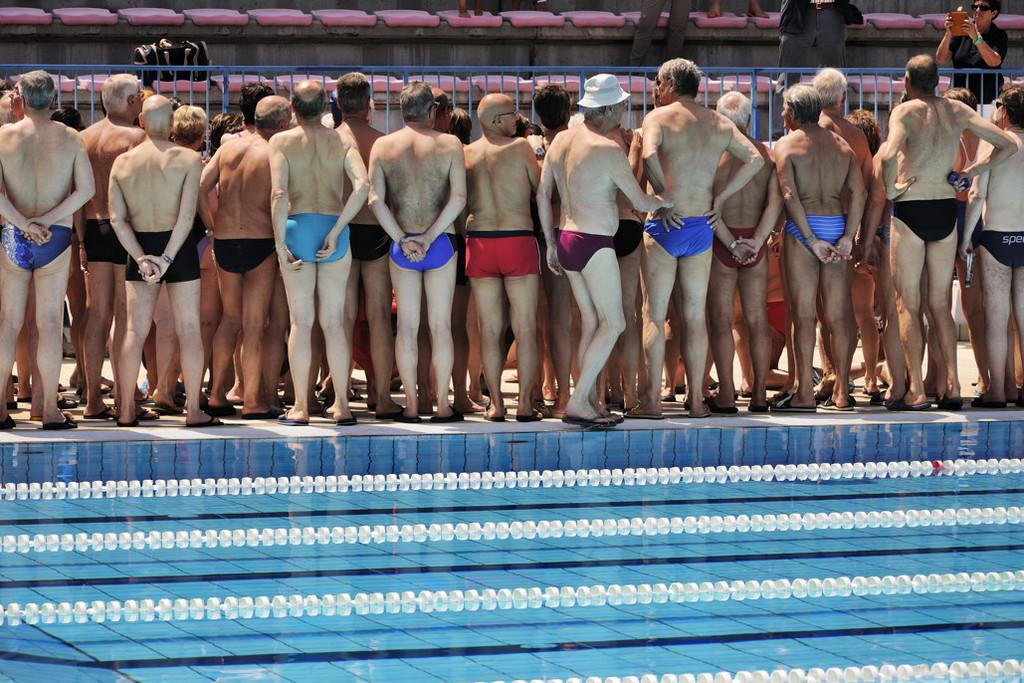What is the main feature in the image? There is a swimming pool in the image. Are there any people in the image? Yes, there are people standing in the image. What else can be seen in the image besides the swimming pool and people? There is a gate in the image. What type of fuel is being used by the art in the image? There is no art or fuel present in the image. Who is the representative of the people in the image? The image does not depict any specific individuals or representatives. 